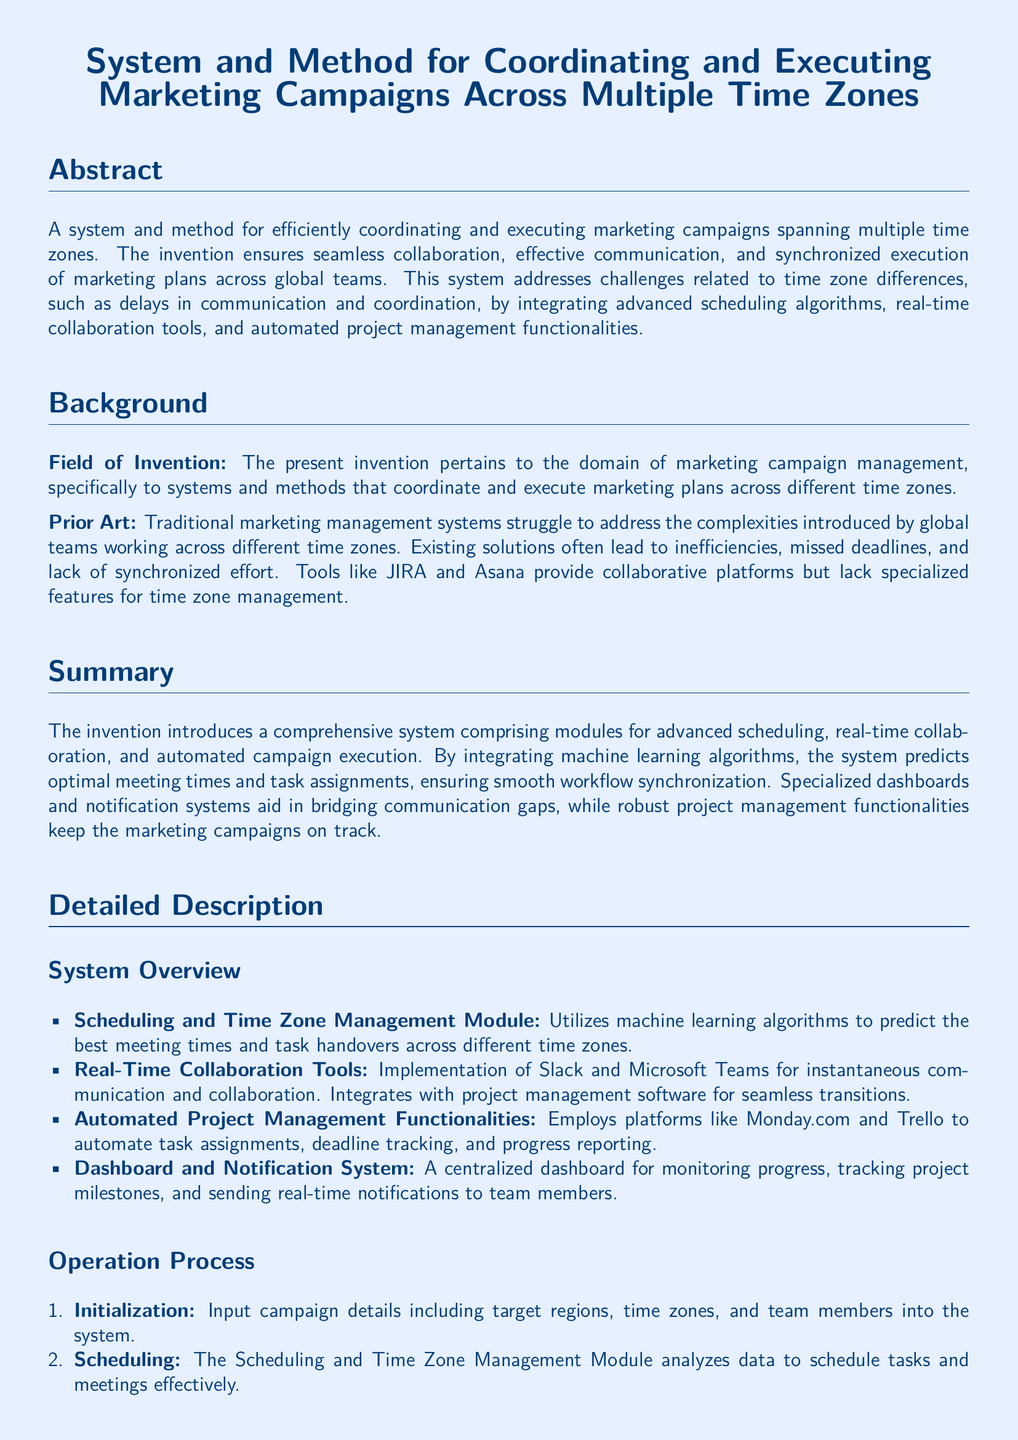What is the title of the invention? The title of the invention is the main heading of the document, which provides a brief overview of its purpose.
Answer: System and Method for Coordinating and Executing Marketing Campaigns Across Multiple Time Zones What module uses machine learning algorithms? The document specifies that a particular module utilizes advanced technology to improve scheduling and task management.
Answer: Scheduling and Time Zone Management Module What are the real-time collaboration tools mentioned? The document lists specific tools that facilitate instant communication among team members.
Answer: Slack and Microsoft Teams How many steps are in the operation process? The number of steps in the operation process is detailed in the document, providing insights into the system’s functionality.
Answer: Five What is the purpose of the Dashboard and Notification System? The document explains the function of this system in tracking progress and communicating updates within the marketing campaign.
Answer: Monitoring progress and sending notifications What is the priority benefit of the proposed system? The main advantage highlighted in the invention is aimed at improving efficiency and coordination across global marketing teams.
Answer: Seamless collaboration Which existing solutions are mentioned as lacking features? The document refers to past tools that do not fully meet the needs of global marketing campaign management.
Answer: JIRA and Asana What is the field of invention? This provides the specific area of application for the invention, clarifying its relevance in marketing.
Answer: Marketing campaign management 